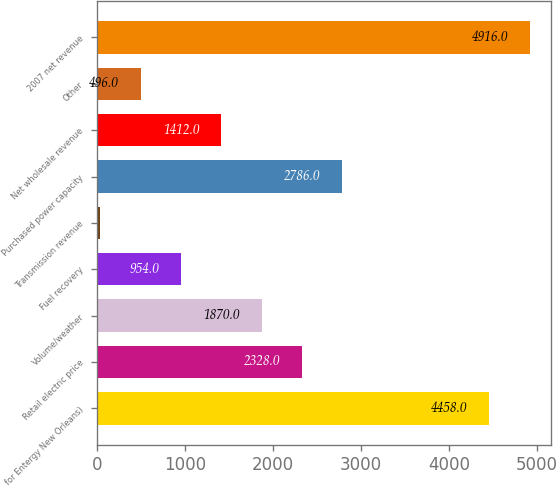Convert chart to OTSL. <chart><loc_0><loc_0><loc_500><loc_500><bar_chart><fcel>for Entergy New Orleans)<fcel>Retail electric price<fcel>Volume/weather<fcel>Fuel recovery<fcel>Transmission revenue<fcel>Purchased power capacity<fcel>Net wholesale revenue<fcel>Other<fcel>2007 net revenue<nl><fcel>4458<fcel>2328<fcel>1870<fcel>954<fcel>38<fcel>2786<fcel>1412<fcel>496<fcel>4916<nl></chart> 